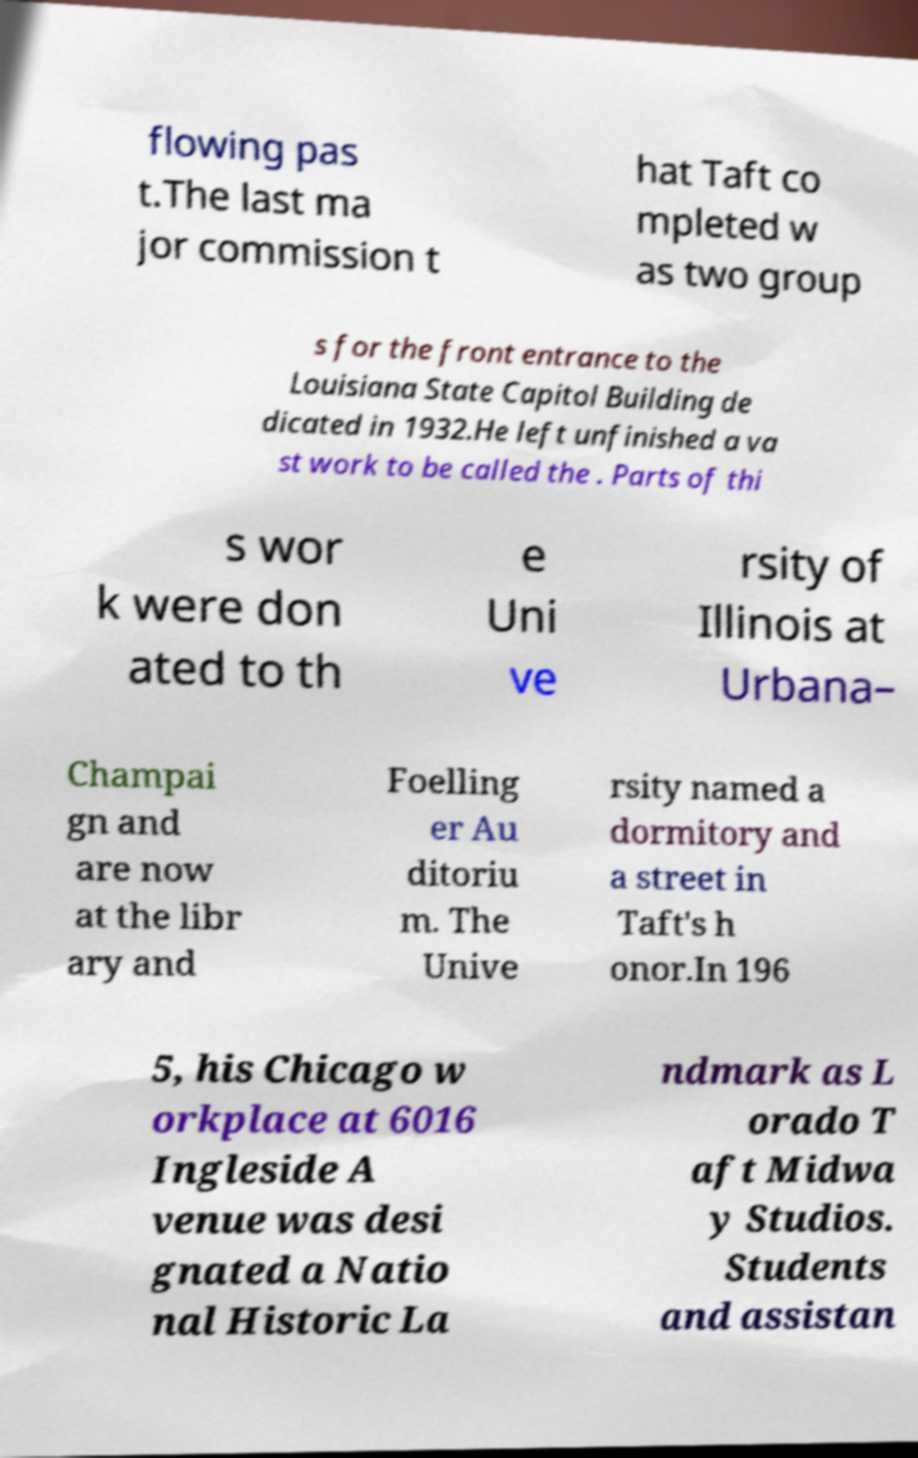What messages or text are displayed in this image? I need them in a readable, typed format. flowing pas t.The last ma jor commission t hat Taft co mpleted w as two group s for the front entrance to the Louisiana State Capitol Building de dicated in 1932.He left unfinished a va st work to be called the . Parts of thi s wor k were don ated to th e Uni ve rsity of Illinois at Urbana– Champai gn and are now at the libr ary and Foelling er Au ditoriu m. The Unive rsity named a dormitory and a street in Taft's h onor.In 196 5, his Chicago w orkplace at 6016 Ingleside A venue was desi gnated a Natio nal Historic La ndmark as L orado T aft Midwa y Studios. Students and assistan 